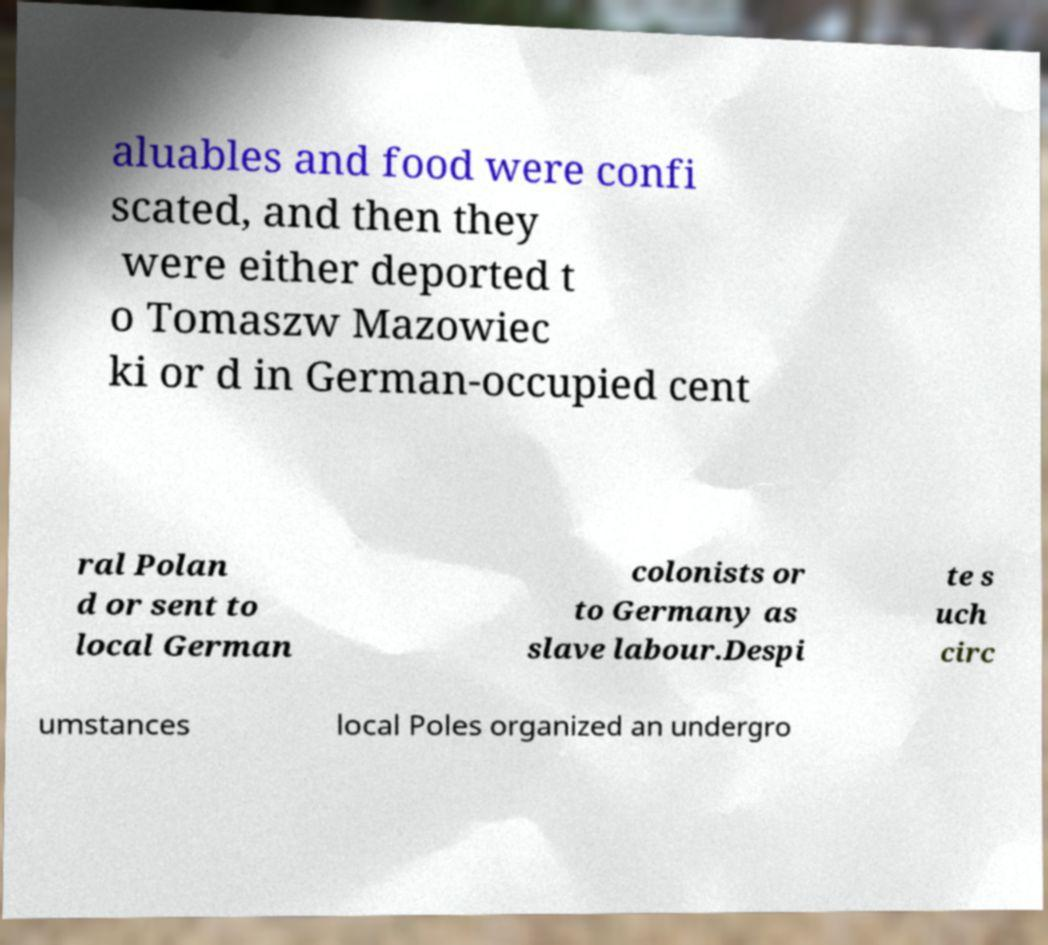Please read and relay the text visible in this image. What does it say? aluables and food were confi scated, and then they were either deported t o Tomaszw Mazowiec ki or d in German-occupied cent ral Polan d or sent to local German colonists or to Germany as slave labour.Despi te s uch circ umstances local Poles organized an undergro 